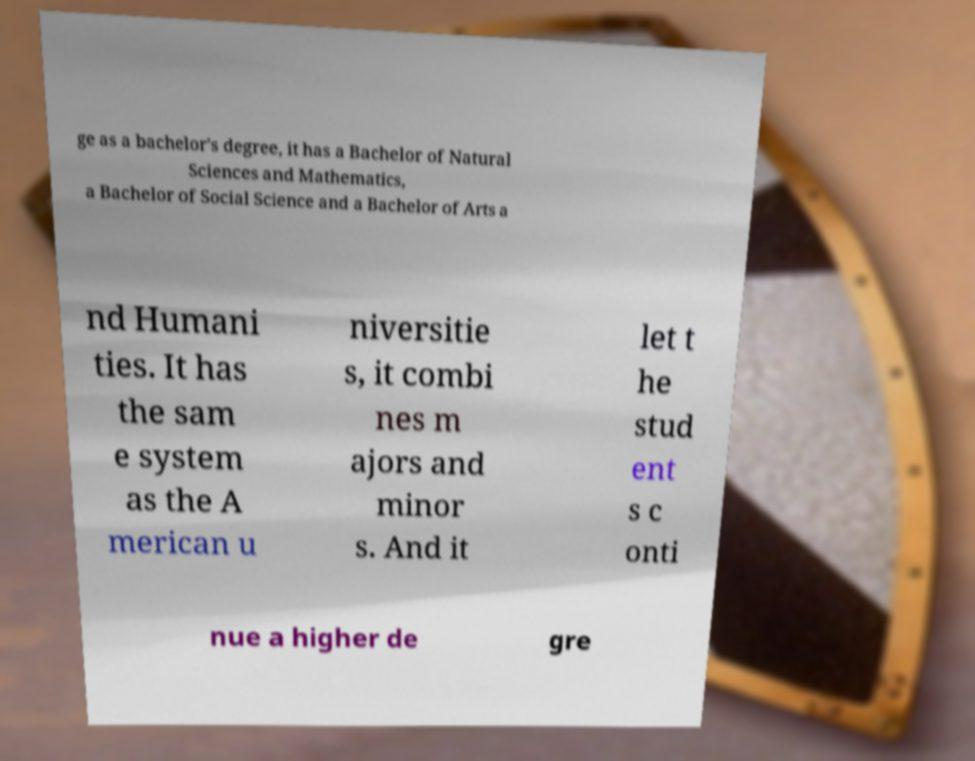Could you assist in decoding the text presented in this image and type it out clearly? ge as a bachelor's degree, it has a Bachelor of Natural Sciences and Mathematics, a Bachelor of Social Science and a Bachelor of Arts a nd Humani ties. It has the sam e system as the A merican u niversitie s, it combi nes m ajors and minor s. And it let t he stud ent s c onti nue a higher de gre 